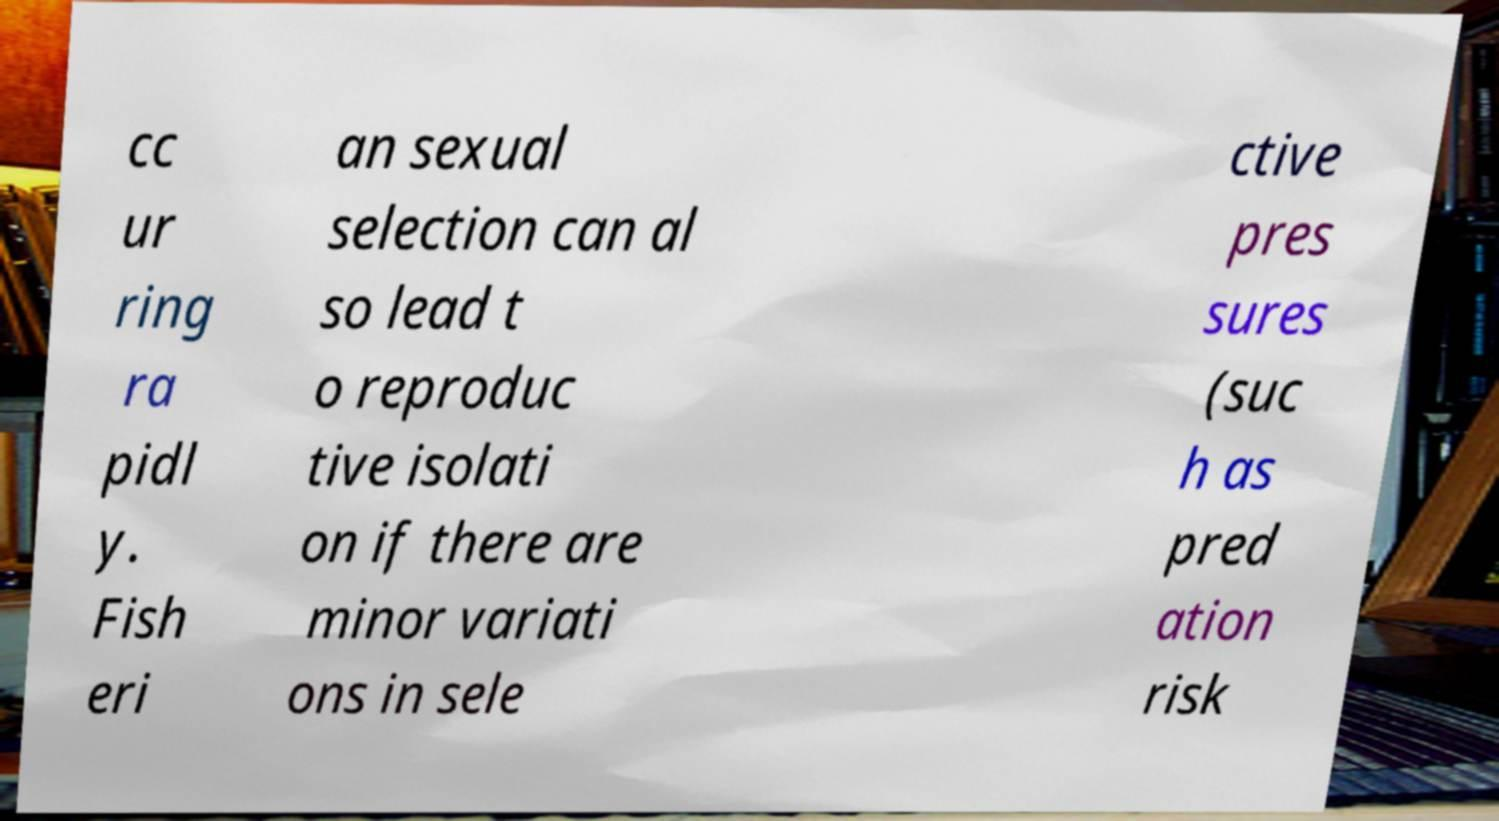I need the written content from this picture converted into text. Can you do that? cc ur ring ra pidl y. Fish eri an sexual selection can al so lead t o reproduc tive isolati on if there are minor variati ons in sele ctive pres sures (suc h as pred ation risk 